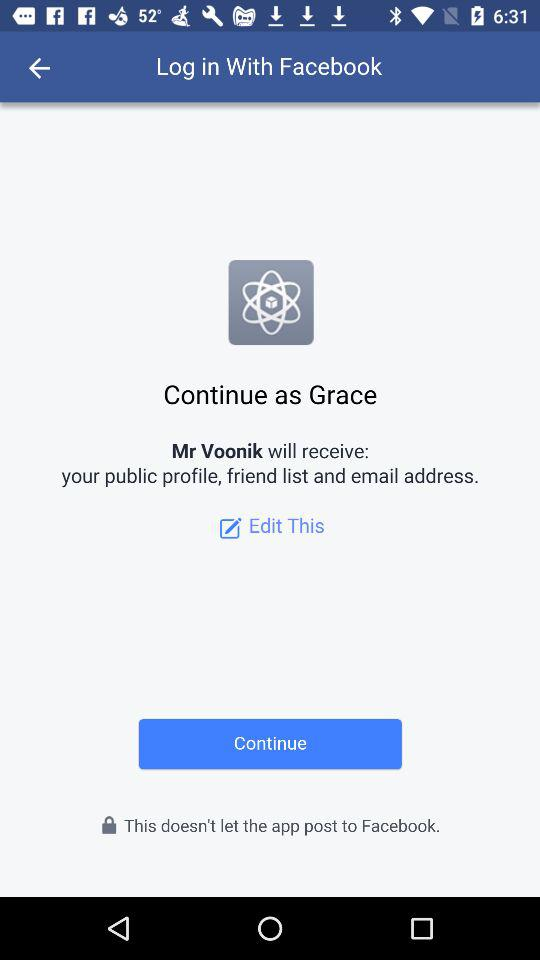What is the name of the user? The name of the user is Grace. 